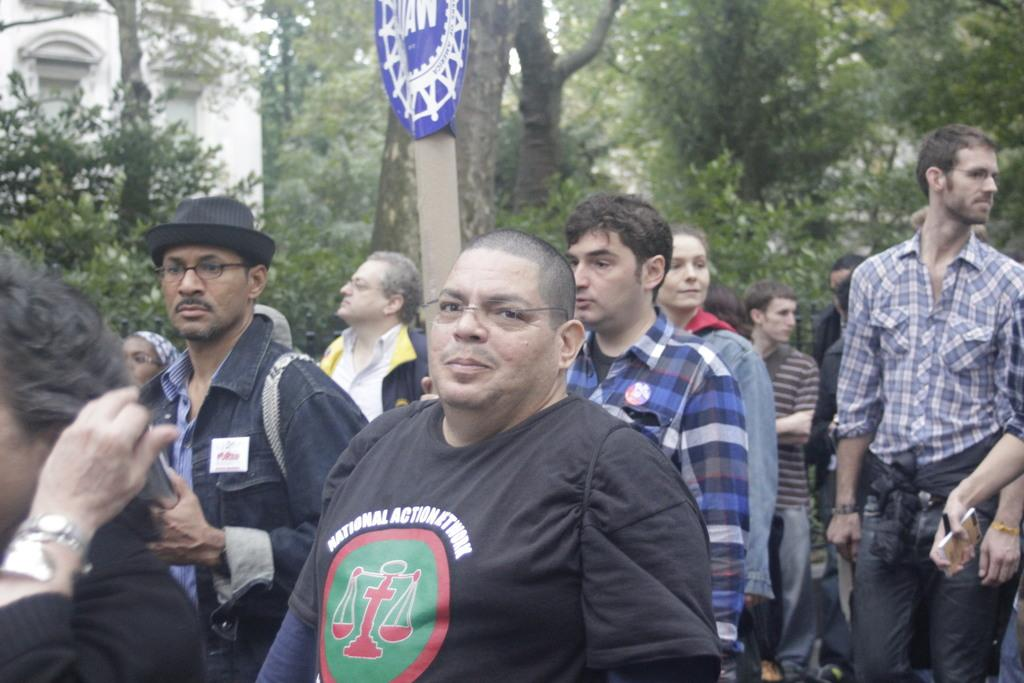<image>
Describe the image concisely. Man wearing a black shirt which says National Action Network. 